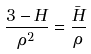Convert formula to latex. <formula><loc_0><loc_0><loc_500><loc_500>\frac { 3 - H } { \rho ^ { 2 } } = \frac { \bar { H } } { \rho }</formula> 